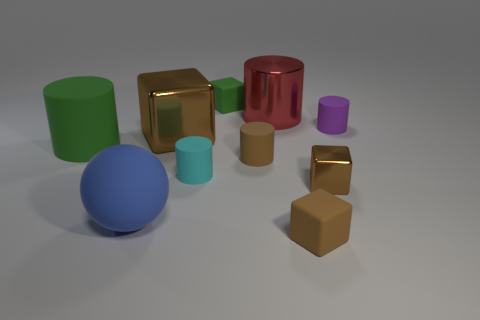What number of cyan cylinders have the same size as the brown matte block?
Make the answer very short. 1. What is the size of the shiny thing that is the same color as the large cube?
Provide a succinct answer. Small. There is a metal block on the right side of the big metal thing that is in front of the tiny purple matte object; what is its color?
Your answer should be very brief. Brown. Are there any rubber blocks of the same color as the small metallic object?
Keep it short and to the point. Yes. There is a block that is the same size as the blue matte sphere; what is its color?
Ensure brevity in your answer.  Brown. Is the green thing that is behind the tiny purple rubber cylinder made of the same material as the sphere?
Offer a terse response. Yes. There is a tiny brown thing that is to the left of the brown matte object that is in front of the big blue sphere; is there a small brown shiny cube behind it?
Provide a succinct answer. No. There is a big metallic thing behind the purple matte cylinder; is it the same shape as the cyan matte object?
Provide a succinct answer. Yes. There is a brown object behind the green thing in front of the purple rubber thing; what is its shape?
Your answer should be very brief. Cube. There is a green matte object behind the tiny matte cylinder that is behind the brown metallic object behind the cyan matte object; what is its size?
Keep it short and to the point. Small. 